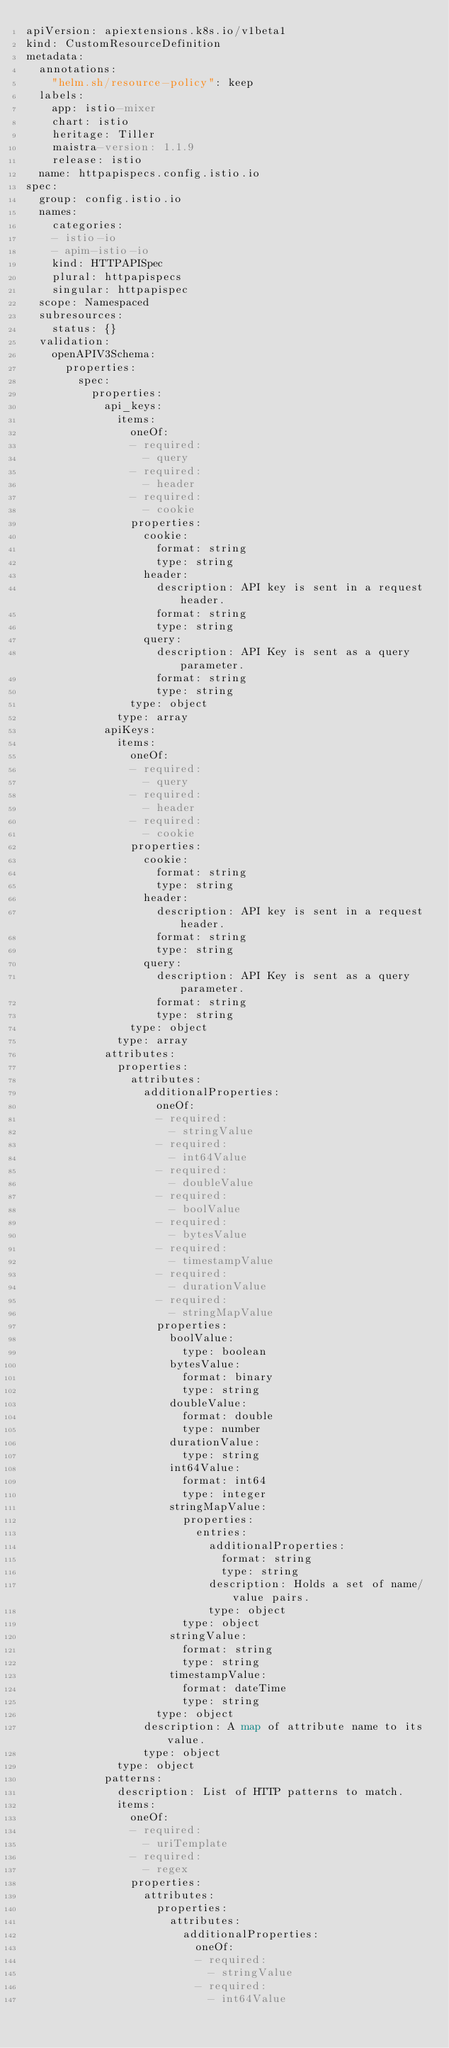<code> <loc_0><loc_0><loc_500><loc_500><_YAML_>apiVersion: apiextensions.k8s.io/v1beta1
kind: CustomResourceDefinition
metadata:
  annotations:
    "helm.sh/resource-policy": keep
  labels:
    app: istio-mixer
    chart: istio
    heritage: Tiller
    maistra-version: 1.1.9
    release: istio
  name: httpapispecs.config.istio.io
spec:
  group: config.istio.io
  names:
    categories:
    - istio-io
    - apim-istio-io
    kind: HTTPAPISpec
    plural: httpapispecs
    singular: httpapispec
  scope: Namespaced
  subresources:
    status: {}
  validation:
    openAPIV3Schema:
      properties:
        spec:
          properties:
            api_keys:
              items:
                oneOf:
                - required:
                  - query
                - required:
                  - header
                - required:
                  - cookie
                properties:
                  cookie:
                    format: string
                    type: string
                  header:
                    description: API key is sent in a request header.
                    format: string
                    type: string
                  query:
                    description: API Key is sent as a query parameter.
                    format: string
                    type: string
                type: object
              type: array
            apiKeys:
              items:
                oneOf:
                - required:
                  - query
                - required:
                  - header
                - required:
                  - cookie
                properties:
                  cookie:
                    format: string
                    type: string
                  header:
                    description: API key is sent in a request header.
                    format: string
                    type: string
                  query:
                    description: API Key is sent as a query parameter.
                    format: string
                    type: string
                type: object
              type: array
            attributes:
              properties:
                attributes:
                  additionalProperties:
                    oneOf:
                    - required:
                      - stringValue
                    - required:
                      - int64Value
                    - required:
                      - doubleValue
                    - required:
                      - boolValue
                    - required:
                      - bytesValue
                    - required:
                      - timestampValue
                    - required:
                      - durationValue
                    - required:
                      - stringMapValue
                    properties:
                      boolValue:
                        type: boolean
                      bytesValue:
                        format: binary
                        type: string
                      doubleValue:
                        format: double
                        type: number
                      durationValue:
                        type: string
                      int64Value:
                        format: int64
                        type: integer
                      stringMapValue:
                        properties:
                          entries:
                            additionalProperties:
                              format: string
                              type: string
                            description: Holds a set of name/value pairs.
                            type: object
                        type: object
                      stringValue:
                        format: string
                        type: string
                      timestampValue:
                        format: dateTime
                        type: string
                    type: object
                  description: A map of attribute name to its value.
                  type: object
              type: object
            patterns:
              description: List of HTTP patterns to match.
              items:
                oneOf:
                - required:
                  - uriTemplate
                - required:
                  - regex
                properties:
                  attributes:
                    properties:
                      attributes:
                        additionalProperties:
                          oneOf:
                          - required:
                            - stringValue
                          - required:
                            - int64Value</code> 